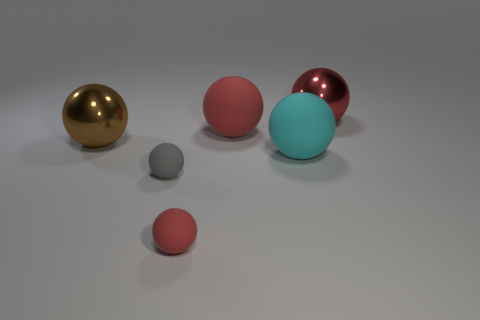There is a small sphere that is right of the small gray rubber ball; what is it made of?
Make the answer very short. Rubber. How big is the red shiny sphere?
Offer a very short reply. Large. Do the brown ball that is in front of the red metal ball and the cyan ball have the same material?
Provide a succinct answer. No. How many red cylinders are there?
Offer a terse response. 0. How many things are red metallic spheres or small red rubber objects?
Provide a short and direct response. 2. There is a red rubber sphere in front of the big matte sphere behind the brown sphere; how many tiny red spheres are left of it?
Your response must be concise. 0. Is the color of the ball on the right side of the big cyan matte thing the same as the rubber sphere behind the big brown metallic thing?
Your response must be concise. Yes. Are there more spheres that are on the left side of the cyan rubber sphere than large red rubber objects that are behind the big red rubber thing?
Offer a very short reply. Yes. What material is the small red thing?
Provide a short and direct response. Rubber. There is a red matte thing in front of the large thing to the left of the tiny gray matte object that is in front of the large cyan matte object; what shape is it?
Provide a succinct answer. Sphere. 